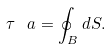<formula> <loc_0><loc_0><loc_500><loc_500>\tau \, \ a = \oint _ { B } d S .</formula> 